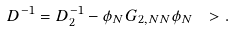<formula> <loc_0><loc_0><loc_500><loc_500>D ^ { - 1 } = D _ { 2 } ^ { - 1 } - \phi _ { N } G _ { 2 , N N } \phi _ { N } \ > .</formula> 